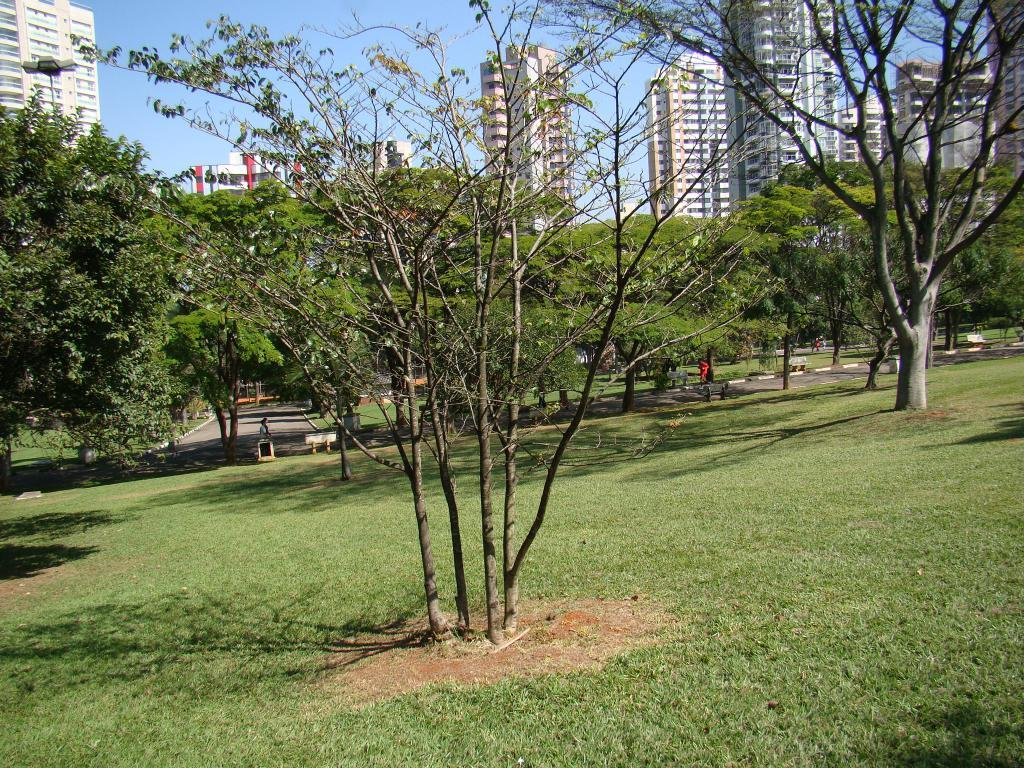What type of vegetation can be seen in the image? There is grass and trees in the image. What are the people in the image doing? There are persons walking through a walkway in the image. What can be seen in the background of the image? There are buildings and a clear sky visible in the background of the image. What type of beam is holding up the trees in the image? There is no beam present in the image; the trees are standing on their own. How many sacks can be seen hanging from the hook in the image? There is no hook or sack present in the image. 